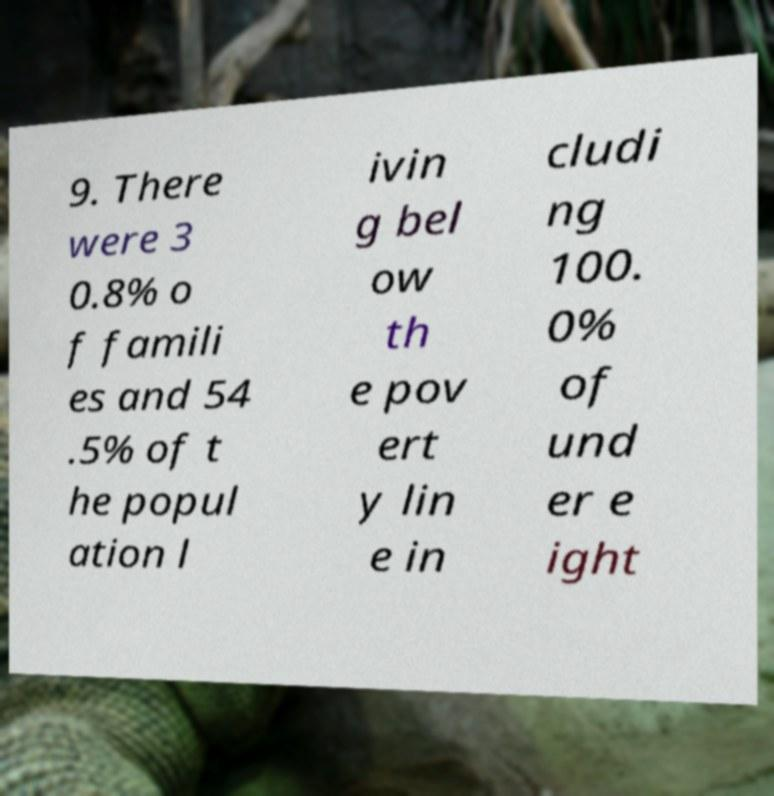There's text embedded in this image that I need extracted. Can you transcribe it verbatim? 9. There were 3 0.8% o f famili es and 54 .5% of t he popul ation l ivin g bel ow th e pov ert y lin e in cludi ng 100. 0% of und er e ight 